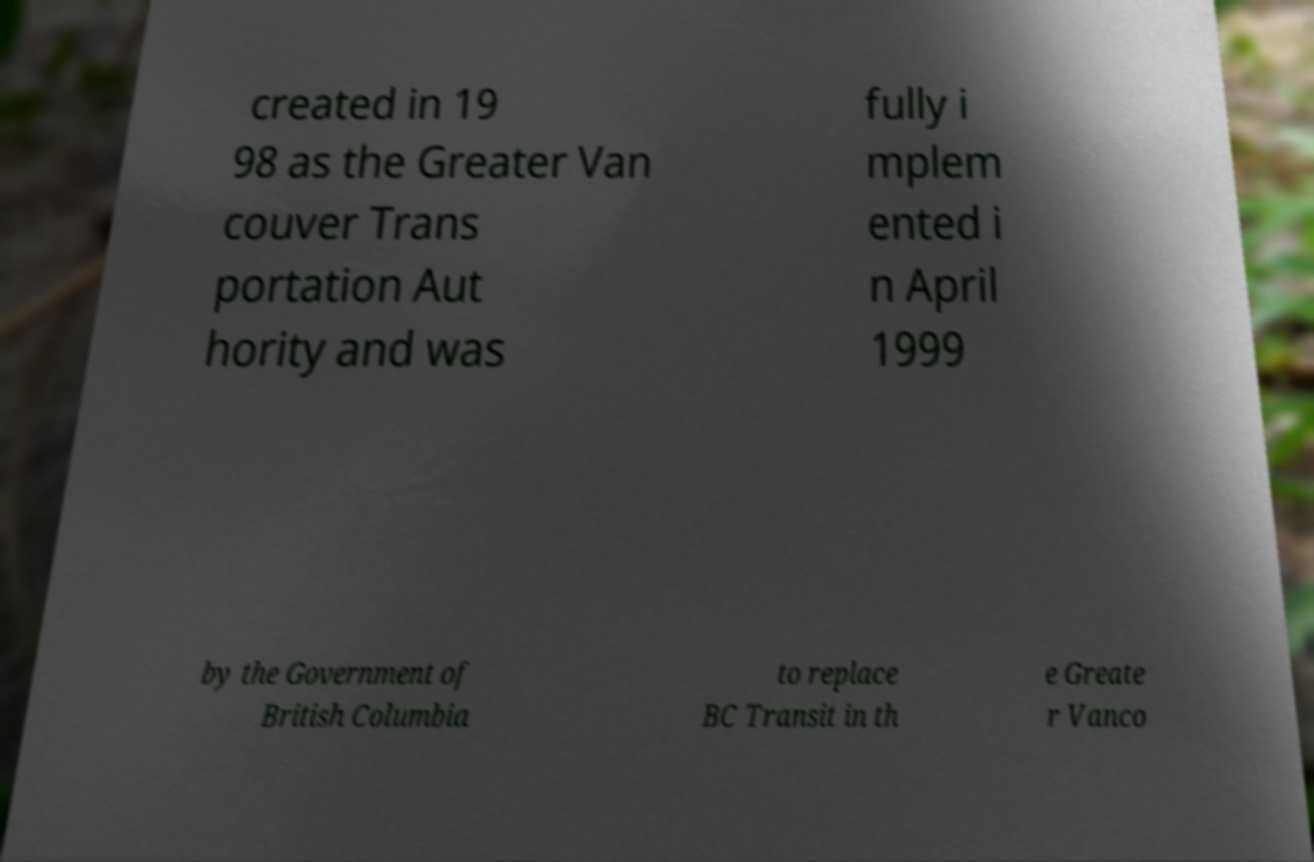Please identify and transcribe the text found in this image. created in 19 98 as the Greater Van couver Trans portation Aut hority and was fully i mplem ented i n April 1999 by the Government of British Columbia to replace BC Transit in th e Greate r Vanco 